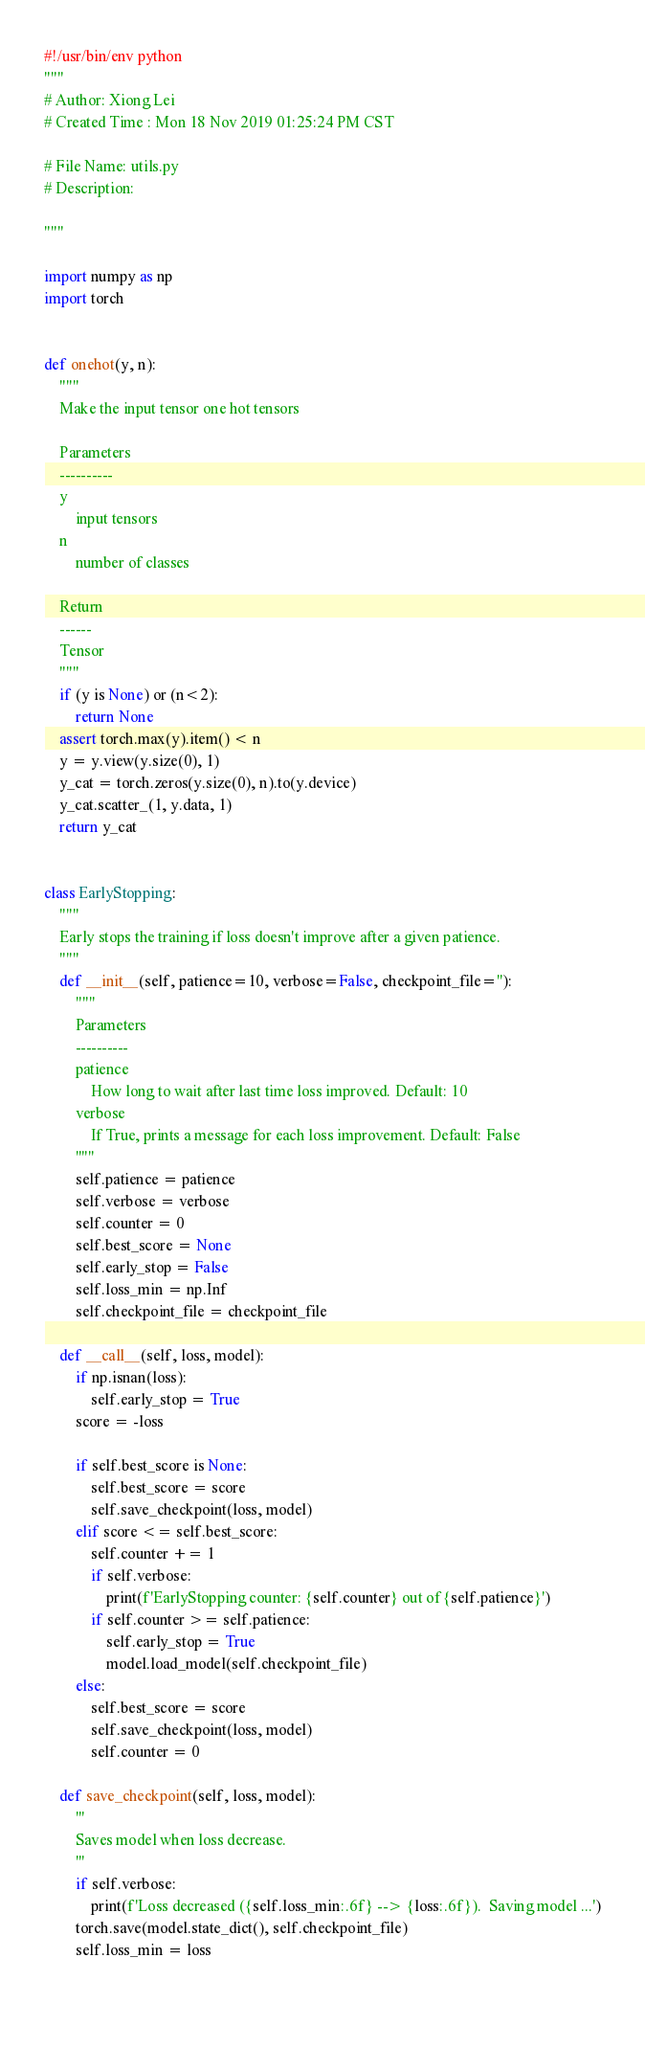Convert code to text. <code><loc_0><loc_0><loc_500><loc_500><_Python_>#!/usr/bin/env python
"""
# Author: Xiong Lei
# Created Time : Mon 18 Nov 2019 01:25:24 PM CST

# File Name: utils.py
# Description:

"""

import numpy as np
import torch


def onehot(y, n):
    """
    Make the input tensor one hot tensors
    
    Parameters
    ----------
    y
        input tensors
    n
        number of classes
        
    Return
    ------
    Tensor
    """
    if (y is None) or (n<2):
        return None
    assert torch.max(y).item() < n
    y = y.view(y.size(0), 1)
    y_cat = torch.zeros(y.size(0), n).to(y.device)
    y_cat.scatter_(1, y.data, 1)
    return y_cat


class EarlyStopping:
    """
    Early stops the training if loss doesn't improve after a given patience.
    """
    def __init__(self, patience=10, verbose=False, checkpoint_file=''):
        """
        Parameters
        ----------
        patience 
            How long to wait after last time loss improved. Default: 10
        verbose
            If True, prints a message for each loss improvement. Default: False
        """
        self.patience = patience
        self.verbose = verbose
        self.counter = 0
        self.best_score = None
        self.early_stop = False
        self.loss_min = np.Inf
        self.checkpoint_file = checkpoint_file

    def __call__(self, loss, model):
        if np.isnan(loss):
            self.early_stop = True
        score = -loss

        if self.best_score is None:
            self.best_score = score
            self.save_checkpoint(loss, model)
        elif score <= self.best_score:
            self.counter += 1
            if self.verbose:
                print(f'EarlyStopping counter: {self.counter} out of {self.patience}')
            if self.counter >= self.patience:
                self.early_stop = True
                model.load_model(self.checkpoint_file)
        else:
            self.best_score = score
            self.save_checkpoint(loss, model)
            self.counter = 0

    def save_checkpoint(self, loss, model):
        '''
        Saves model when loss decrease.
        '''
        if self.verbose:
            print(f'Loss decreased ({self.loss_min:.6f} --> {loss:.6f}).  Saving model ...')
        torch.save(model.state_dict(), self.checkpoint_file)
        self.loss_min = loss
        
    </code> 